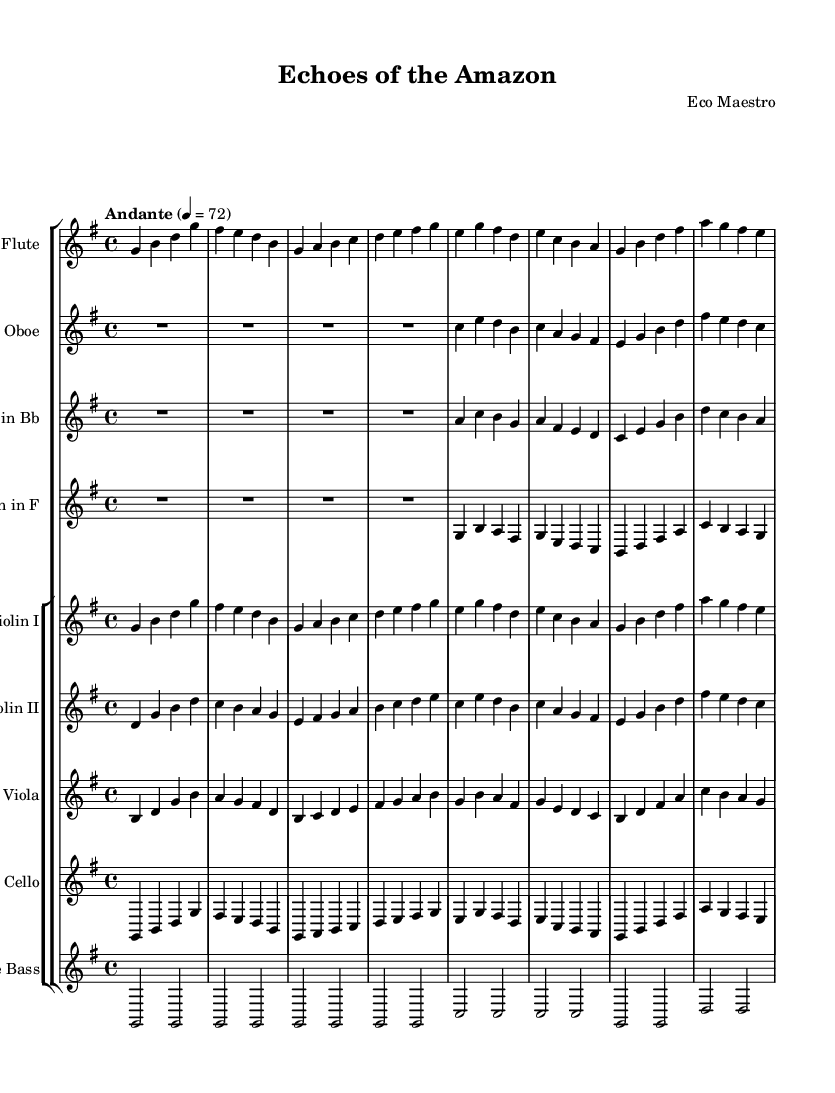What is the key signature of this piece? The key signature is G major, which has one sharp (F#). This is indicated by the key signature mark at the beginning of the staff.
Answer: G major What is the time signature? The time signature is 4/4, as shown at the beginning of the sheet music. This means there are four beats in a measure and the quarter note gets one beat.
Answer: 4/4 What is the tempo marking? The tempo marking is "Andante" with a metronome marking of 72. This indicates a moderately slow pace for the piece.
Answer: Andante, 72 Which instruments are considered woodwinds in this composition? The instruments classified as woodwinds in this piece are the Flute, Oboe, and Clarinet. These are indicated in the score layout, grouped within the woodwind sections.
Answer: Flute, Oboe, Clarinet How many measures are present in the string section? By counting the measures for each string instrument part (Violin I, Violin II, Viola, Cello, Double Bass), we find that there are a total of 8 measures in the string section.
Answer: 8 What is the theme of this orchestral piece? The title "Echoes of the Amazon" suggests that the piece is inspired by the Amazon rainforest, potentially evoking sounds from nature and environmental themes through its musical motifs.
Answer: Environmental themes Which instrument plays the lowest pitch in this score? The Double Bass typically plays the lowest pitch in orchestral arrangements. It is indicated at the bottom of the staff group, confirming its role in providing bass foundations.
Answer: Double Bass 